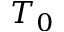Convert formula to latex. <formula><loc_0><loc_0><loc_500><loc_500>T _ { 0 }</formula> 